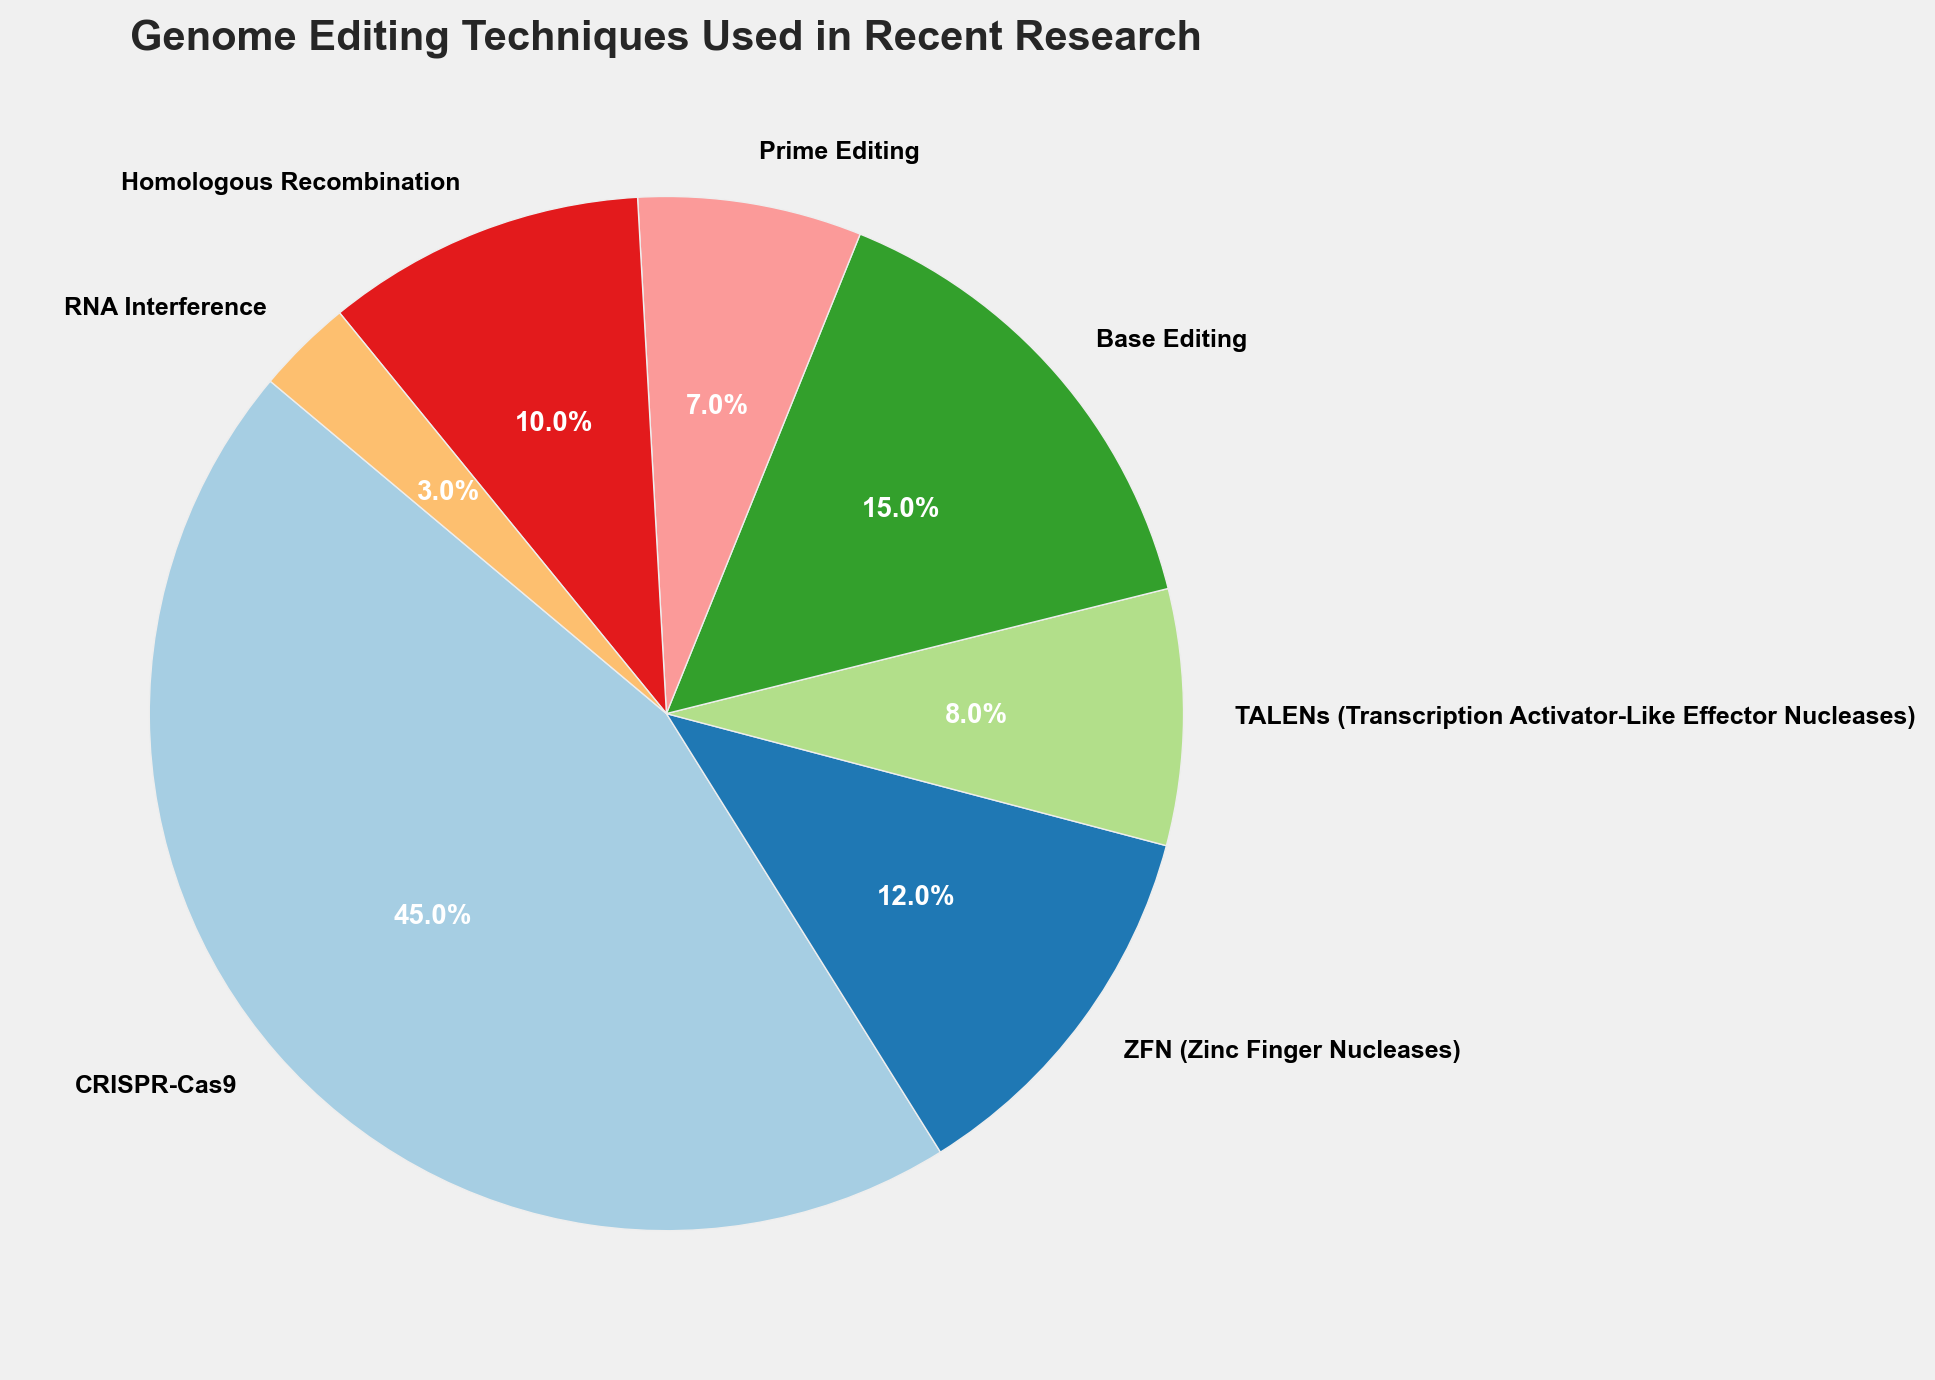What percentage of publications used CRISPR-Cas9 and RNA Interference combined? CRISPR-Cas9 contributes 45 and RNA Interference contributes 3 to the total count. The sum is 45 + 3 = 48. To find the percentage, 48 / (45+12+8+15+7+10+3) * 100 ≈ 48 / 100 * 100 = 48.0%
Answer: 48.0% Which technique is used the least? By examining the pie chart, RNA Interference has the smallest portion.
Answer: RNA Interference How many more publications used Base Editing compared to Prime Editing? Base Editing appears 15 times and Prime Editing appears 7 times. The difference is 15 - 7 = 8.
Answer: 8 Is the number of publications using TALENs greater than those using Homologous Recombination? TALENs appear 8 times whereas Homologous Recombination appears 10 times. 8 is not greater than 10.
Answer: No What is the combined percentage of Base Editing and Prime Editing? Base Editing is 15 and Prime Editing is 7. Sum is 15 + 7 = 22. The total count of all techniques is 100. Thus, (22 / 100) * 100 = 22.0%.
Answer: 22.0% Which technique is represented by the largest segment in the pie chart? The largest segment in the pie chart corresponds to CRISPR-Cas9.
Answer: CRISPR-Cas9 Do ZFN and TALENs combined use exceed the use of CRISPR-Cas9? ZFN is 12 and TALENs is 8 for a total of 12 + 8 = 20. CRISPR-Cas9 is 45. 20 is less than 45.
Answer: No By how much does Homologous Recombination usage exceed RNA Interference usage? Homologous Recombination is 10 and RNA Interference is 3. The difference is 10 - 3 = 7.
Answer: 7 